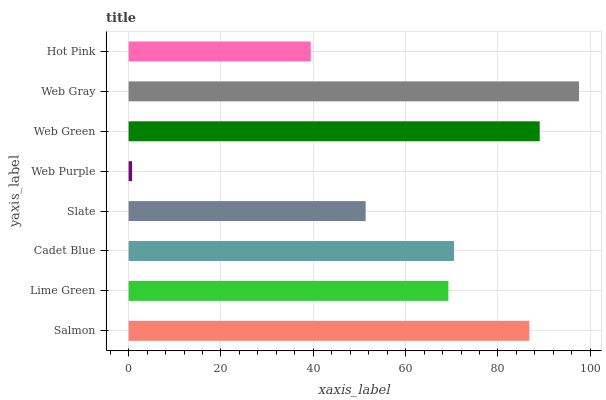Is Web Purple the minimum?
Answer yes or no. Yes. Is Web Gray the maximum?
Answer yes or no. Yes. Is Lime Green the minimum?
Answer yes or no. No. Is Lime Green the maximum?
Answer yes or no. No. Is Salmon greater than Lime Green?
Answer yes or no. Yes. Is Lime Green less than Salmon?
Answer yes or no. Yes. Is Lime Green greater than Salmon?
Answer yes or no. No. Is Salmon less than Lime Green?
Answer yes or no. No. Is Cadet Blue the high median?
Answer yes or no. Yes. Is Lime Green the low median?
Answer yes or no. Yes. Is Lime Green the high median?
Answer yes or no. No. Is Web Purple the low median?
Answer yes or no. No. 